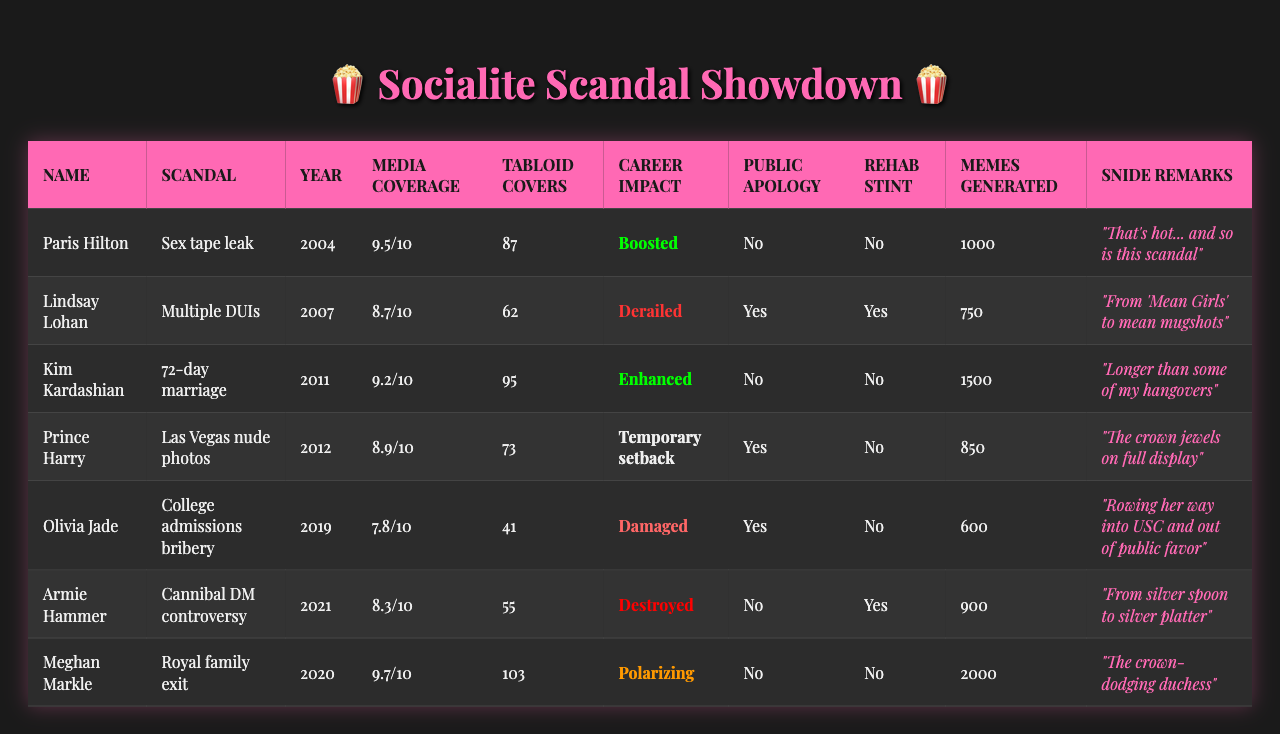What is the media coverage intensity of Olivia Jade's scandal? According to the table, Olivia Jade's scandal regarding college admissions bribery has a media coverage intensity of 7.8.
Answer: 7.8 Which socialite generated the most memes? The table shows the number of memes generated for each scandal, and Kim Kardashian's scandal produced the highest number with 1500 memes.
Answer: 1500 How many tabloid front pages featured Prince Harry's scandal? The table indicates that Prince Harry's scandal had 73 tabloid front pages dedicated to it.
Answer: 73 Did Paris Hilton issue a public apology? The table indicates that Paris Hilton did not issue a public apology regarding her scandal.
Answer: No Which scandal had the highest media coverage intensity, and what was it? By reviewing the table, Meghan Markle's royal family exit had the highest media coverage intensity at 9.7.
Answer: 9.7 (Meghan Markle) What is the total number of tabloid front pages covered for all scandals? Summing the tabloid covers results in 87 (Paris Hilton) + 62 (Lindsay Lohan) + 95 (Kim Kardashian) + 73 (Prince Harry) + 41 (Olivia Jade) + 55 (Armie Hammer) + 103 (Meghan Markle) = 516 front pages.
Answer: 516 Who had a career impact categorized as "Derailed"? From the table, Lindsay Lohan's multiple DUIs scandal is categorized as having derailed her career.
Answer: Lindsay Lohan What is the average media coverage intensity for scandals that resulted in a "Boosted" career impact? Only Paris Hilton's scandal qualifies with a media coverage intensity of 9.5, leading to an average of 9.5 for this category.
Answer: 9.5 How many scandals involved a rehab stint? Looking at the table, Lindsay Lohan and Armie Hammer both had rehabs, indicating 2 scandals involved a rehab stint.
Answer: 2 Which socialite's scandal received the most tabloid covers among those that were marked as "Damaged"? Olivia Jade's scandal received 41 tabloid covers, and she is categorized as having damaged her career.
Answer: 41 Did any of the socialites with a "destroyed" career impact issue a public apology? The table indicates that Armie Hammer, who had a destroyed career impact, did not issue a public apology.
Answer: No 